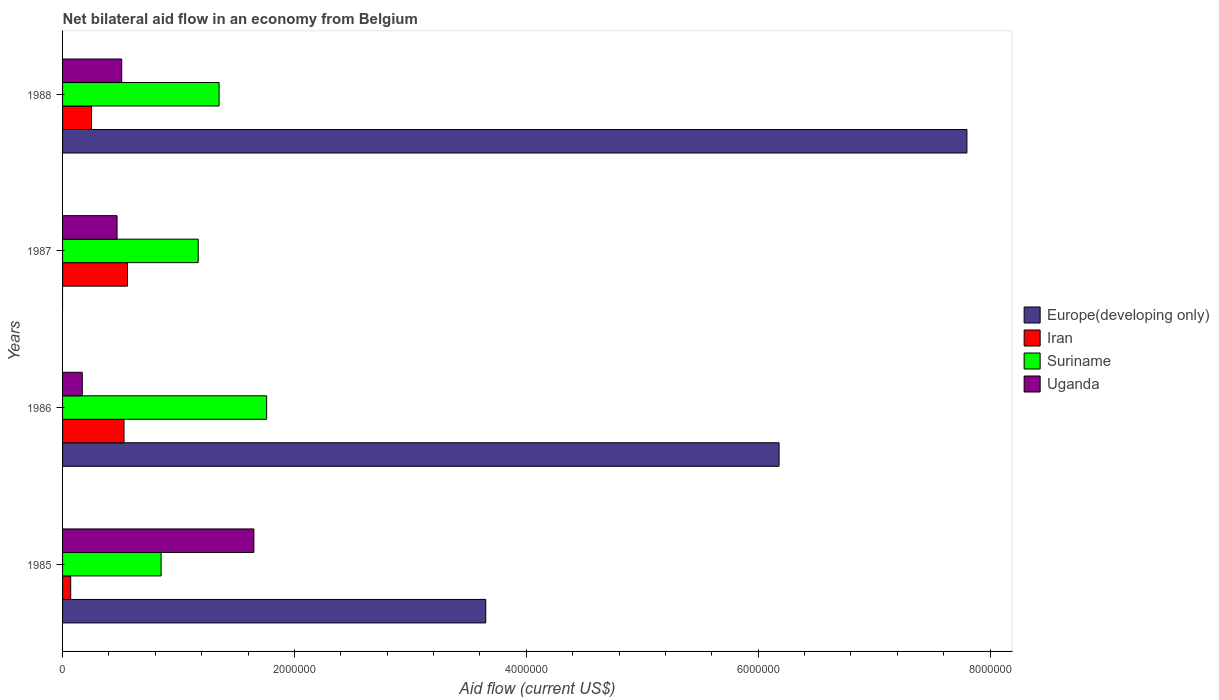How many different coloured bars are there?
Provide a succinct answer. 4. Are the number of bars per tick equal to the number of legend labels?
Your answer should be very brief. No. Are the number of bars on each tick of the Y-axis equal?
Give a very brief answer. No. How many bars are there on the 1st tick from the top?
Offer a terse response. 4. How many bars are there on the 3rd tick from the bottom?
Provide a short and direct response. 3. What is the label of the 1st group of bars from the top?
Offer a terse response. 1988. What is the net bilateral aid flow in Uganda in 1985?
Your answer should be very brief. 1.65e+06. Across all years, what is the maximum net bilateral aid flow in Europe(developing only)?
Provide a short and direct response. 7.80e+06. Across all years, what is the minimum net bilateral aid flow in Suriname?
Keep it short and to the point. 8.50e+05. What is the total net bilateral aid flow in Europe(developing only) in the graph?
Your answer should be compact. 1.76e+07. What is the difference between the net bilateral aid flow in Suriname in 1985 and that in 1987?
Give a very brief answer. -3.20e+05. What is the difference between the net bilateral aid flow in Europe(developing only) in 1985 and the net bilateral aid flow in Iran in 1986?
Ensure brevity in your answer.  3.12e+06. In the year 1986, what is the difference between the net bilateral aid flow in Iran and net bilateral aid flow in Suriname?
Your response must be concise. -1.23e+06. In how many years, is the net bilateral aid flow in Europe(developing only) greater than 5200000 US$?
Give a very brief answer. 2. What is the ratio of the net bilateral aid flow in Iran in 1986 to that in 1988?
Offer a terse response. 2.12. Is the net bilateral aid flow in Uganda in 1986 less than that in 1988?
Make the answer very short. Yes. Is the difference between the net bilateral aid flow in Iran in 1987 and 1988 greater than the difference between the net bilateral aid flow in Suriname in 1987 and 1988?
Provide a succinct answer. Yes. What is the difference between the highest and the second highest net bilateral aid flow in Suriname?
Ensure brevity in your answer.  4.10e+05. What is the difference between the highest and the lowest net bilateral aid flow in Europe(developing only)?
Your answer should be very brief. 7.80e+06. In how many years, is the net bilateral aid flow in Uganda greater than the average net bilateral aid flow in Uganda taken over all years?
Provide a succinct answer. 1. Is it the case that in every year, the sum of the net bilateral aid flow in Suriname and net bilateral aid flow in Iran is greater than the sum of net bilateral aid flow in Uganda and net bilateral aid flow in Europe(developing only)?
Offer a terse response. No. Is it the case that in every year, the sum of the net bilateral aid flow in Europe(developing only) and net bilateral aid flow in Suriname is greater than the net bilateral aid flow in Uganda?
Offer a terse response. Yes. Are all the bars in the graph horizontal?
Give a very brief answer. Yes. How many years are there in the graph?
Offer a terse response. 4. What is the difference between two consecutive major ticks on the X-axis?
Your answer should be very brief. 2.00e+06. Are the values on the major ticks of X-axis written in scientific E-notation?
Make the answer very short. No. Does the graph contain any zero values?
Provide a succinct answer. Yes. Does the graph contain grids?
Provide a short and direct response. No. What is the title of the graph?
Your answer should be compact. Net bilateral aid flow in an economy from Belgium. Does "Fragile and conflict affected situations" appear as one of the legend labels in the graph?
Your answer should be very brief. No. What is the label or title of the X-axis?
Give a very brief answer. Aid flow (current US$). What is the Aid flow (current US$) in Europe(developing only) in 1985?
Your response must be concise. 3.65e+06. What is the Aid flow (current US$) in Suriname in 1985?
Provide a succinct answer. 8.50e+05. What is the Aid flow (current US$) of Uganda in 1985?
Ensure brevity in your answer.  1.65e+06. What is the Aid flow (current US$) of Europe(developing only) in 1986?
Offer a terse response. 6.18e+06. What is the Aid flow (current US$) in Iran in 1986?
Provide a succinct answer. 5.30e+05. What is the Aid flow (current US$) in Suriname in 1986?
Your answer should be very brief. 1.76e+06. What is the Aid flow (current US$) in Uganda in 1986?
Provide a short and direct response. 1.70e+05. What is the Aid flow (current US$) of Europe(developing only) in 1987?
Offer a terse response. 0. What is the Aid flow (current US$) in Iran in 1987?
Make the answer very short. 5.60e+05. What is the Aid flow (current US$) of Suriname in 1987?
Offer a terse response. 1.17e+06. What is the Aid flow (current US$) in Europe(developing only) in 1988?
Ensure brevity in your answer.  7.80e+06. What is the Aid flow (current US$) of Iran in 1988?
Your response must be concise. 2.50e+05. What is the Aid flow (current US$) in Suriname in 1988?
Offer a terse response. 1.35e+06. What is the Aid flow (current US$) of Uganda in 1988?
Give a very brief answer. 5.10e+05. Across all years, what is the maximum Aid flow (current US$) in Europe(developing only)?
Make the answer very short. 7.80e+06. Across all years, what is the maximum Aid flow (current US$) in Iran?
Make the answer very short. 5.60e+05. Across all years, what is the maximum Aid flow (current US$) in Suriname?
Give a very brief answer. 1.76e+06. Across all years, what is the maximum Aid flow (current US$) in Uganda?
Offer a very short reply. 1.65e+06. Across all years, what is the minimum Aid flow (current US$) in Iran?
Make the answer very short. 7.00e+04. Across all years, what is the minimum Aid flow (current US$) in Suriname?
Your response must be concise. 8.50e+05. Across all years, what is the minimum Aid flow (current US$) of Uganda?
Provide a short and direct response. 1.70e+05. What is the total Aid flow (current US$) of Europe(developing only) in the graph?
Keep it short and to the point. 1.76e+07. What is the total Aid flow (current US$) in Iran in the graph?
Offer a very short reply. 1.41e+06. What is the total Aid flow (current US$) of Suriname in the graph?
Keep it short and to the point. 5.13e+06. What is the total Aid flow (current US$) of Uganda in the graph?
Your response must be concise. 2.80e+06. What is the difference between the Aid flow (current US$) of Europe(developing only) in 1985 and that in 1986?
Give a very brief answer. -2.53e+06. What is the difference between the Aid flow (current US$) in Iran in 1985 and that in 1986?
Keep it short and to the point. -4.60e+05. What is the difference between the Aid flow (current US$) in Suriname in 1985 and that in 1986?
Your response must be concise. -9.10e+05. What is the difference between the Aid flow (current US$) in Uganda in 1985 and that in 1986?
Provide a short and direct response. 1.48e+06. What is the difference between the Aid flow (current US$) in Iran in 1985 and that in 1987?
Give a very brief answer. -4.90e+05. What is the difference between the Aid flow (current US$) in Suriname in 1985 and that in 1987?
Keep it short and to the point. -3.20e+05. What is the difference between the Aid flow (current US$) of Uganda in 1985 and that in 1987?
Ensure brevity in your answer.  1.18e+06. What is the difference between the Aid flow (current US$) in Europe(developing only) in 1985 and that in 1988?
Your answer should be compact. -4.15e+06. What is the difference between the Aid flow (current US$) of Iran in 1985 and that in 1988?
Provide a short and direct response. -1.80e+05. What is the difference between the Aid flow (current US$) in Suriname in 1985 and that in 1988?
Ensure brevity in your answer.  -5.00e+05. What is the difference between the Aid flow (current US$) in Uganda in 1985 and that in 1988?
Your answer should be compact. 1.14e+06. What is the difference between the Aid flow (current US$) of Suriname in 1986 and that in 1987?
Your answer should be very brief. 5.90e+05. What is the difference between the Aid flow (current US$) of Europe(developing only) in 1986 and that in 1988?
Ensure brevity in your answer.  -1.62e+06. What is the difference between the Aid flow (current US$) of Uganda in 1987 and that in 1988?
Make the answer very short. -4.00e+04. What is the difference between the Aid flow (current US$) of Europe(developing only) in 1985 and the Aid flow (current US$) of Iran in 1986?
Make the answer very short. 3.12e+06. What is the difference between the Aid flow (current US$) of Europe(developing only) in 1985 and the Aid flow (current US$) of Suriname in 1986?
Keep it short and to the point. 1.89e+06. What is the difference between the Aid flow (current US$) of Europe(developing only) in 1985 and the Aid flow (current US$) of Uganda in 1986?
Your response must be concise. 3.48e+06. What is the difference between the Aid flow (current US$) in Iran in 1985 and the Aid flow (current US$) in Suriname in 1986?
Offer a terse response. -1.69e+06. What is the difference between the Aid flow (current US$) of Suriname in 1985 and the Aid flow (current US$) of Uganda in 1986?
Offer a terse response. 6.80e+05. What is the difference between the Aid flow (current US$) of Europe(developing only) in 1985 and the Aid flow (current US$) of Iran in 1987?
Offer a terse response. 3.09e+06. What is the difference between the Aid flow (current US$) of Europe(developing only) in 1985 and the Aid flow (current US$) of Suriname in 1987?
Provide a short and direct response. 2.48e+06. What is the difference between the Aid flow (current US$) of Europe(developing only) in 1985 and the Aid flow (current US$) of Uganda in 1987?
Provide a succinct answer. 3.18e+06. What is the difference between the Aid flow (current US$) of Iran in 1985 and the Aid flow (current US$) of Suriname in 1987?
Your response must be concise. -1.10e+06. What is the difference between the Aid flow (current US$) of Iran in 1985 and the Aid flow (current US$) of Uganda in 1987?
Ensure brevity in your answer.  -4.00e+05. What is the difference between the Aid flow (current US$) in Europe(developing only) in 1985 and the Aid flow (current US$) in Iran in 1988?
Your answer should be compact. 3.40e+06. What is the difference between the Aid flow (current US$) in Europe(developing only) in 1985 and the Aid flow (current US$) in Suriname in 1988?
Keep it short and to the point. 2.30e+06. What is the difference between the Aid flow (current US$) of Europe(developing only) in 1985 and the Aid flow (current US$) of Uganda in 1988?
Offer a terse response. 3.14e+06. What is the difference between the Aid flow (current US$) in Iran in 1985 and the Aid flow (current US$) in Suriname in 1988?
Ensure brevity in your answer.  -1.28e+06. What is the difference between the Aid flow (current US$) in Iran in 1985 and the Aid flow (current US$) in Uganda in 1988?
Provide a short and direct response. -4.40e+05. What is the difference between the Aid flow (current US$) of Europe(developing only) in 1986 and the Aid flow (current US$) of Iran in 1987?
Give a very brief answer. 5.62e+06. What is the difference between the Aid flow (current US$) in Europe(developing only) in 1986 and the Aid flow (current US$) in Suriname in 1987?
Keep it short and to the point. 5.01e+06. What is the difference between the Aid flow (current US$) of Europe(developing only) in 1986 and the Aid flow (current US$) of Uganda in 1987?
Ensure brevity in your answer.  5.71e+06. What is the difference between the Aid flow (current US$) of Iran in 1986 and the Aid flow (current US$) of Suriname in 1987?
Your response must be concise. -6.40e+05. What is the difference between the Aid flow (current US$) in Suriname in 1986 and the Aid flow (current US$) in Uganda in 1987?
Offer a very short reply. 1.29e+06. What is the difference between the Aid flow (current US$) of Europe(developing only) in 1986 and the Aid flow (current US$) of Iran in 1988?
Provide a short and direct response. 5.93e+06. What is the difference between the Aid flow (current US$) in Europe(developing only) in 1986 and the Aid flow (current US$) in Suriname in 1988?
Your response must be concise. 4.83e+06. What is the difference between the Aid flow (current US$) of Europe(developing only) in 1986 and the Aid flow (current US$) of Uganda in 1988?
Make the answer very short. 5.67e+06. What is the difference between the Aid flow (current US$) in Iran in 1986 and the Aid flow (current US$) in Suriname in 1988?
Provide a short and direct response. -8.20e+05. What is the difference between the Aid flow (current US$) in Suriname in 1986 and the Aid flow (current US$) in Uganda in 1988?
Offer a very short reply. 1.25e+06. What is the difference between the Aid flow (current US$) in Iran in 1987 and the Aid flow (current US$) in Suriname in 1988?
Provide a short and direct response. -7.90e+05. What is the difference between the Aid flow (current US$) of Iran in 1987 and the Aid flow (current US$) of Uganda in 1988?
Provide a short and direct response. 5.00e+04. What is the difference between the Aid flow (current US$) of Suriname in 1987 and the Aid flow (current US$) of Uganda in 1988?
Give a very brief answer. 6.60e+05. What is the average Aid flow (current US$) of Europe(developing only) per year?
Provide a succinct answer. 4.41e+06. What is the average Aid flow (current US$) in Iran per year?
Keep it short and to the point. 3.52e+05. What is the average Aid flow (current US$) of Suriname per year?
Offer a terse response. 1.28e+06. What is the average Aid flow (current US$) of Uganda per year?
Offer a very short reply. 7.00e+05. In the year 1985, what is the difference between the Aid flow (current US$) in Europe(developing only) and Aid flow (current US$) in Iran?
Offer a very short reply. 3.58e+06. In the year 1985, what is the difference between the Aid flow (current US$) of Europe(developing only) and Aid flow (current US$) of Suriname?
Ensure brevity in your answer.  2.80e+06. In the year 1985, what is the difference between the Aid flow (current US$) in Europe(developing only) and Aid flow (current US$) in Uganda?
Provide a succinct answer. 2.00e+06. In the year 1985, what is the difference between the Aid flow (current US$) of Iran and Aid flow (current US$) of Suriname?
Give a very brief answer. -7.80e+05. In the year 1985, what is the difference between the Aid flow (current US$) of Iran and Aid flow (current US$) of Uganda?
Give a very brief answer. -1.58e+06. In the year 1985, what is the difference between the Aid flow (current US$) in Suriname and Aid flow (current US$) in Uganda?
Keep it short and to the point. -8.00e+05. In the year 1986, what is the difference between the Aid flow (current US$) of Europe(developing only) and Aid flow (current US$) of Iran?
Keep it short and to the point. 5.65e+06. In the year 1986, what is the difference between the Aid flow (current US$) of Europe(developing only) and Aid flow (current US$) of Suriname?
Your answer should be very brief. 4.42e+06. In the year 1986, what is the difference between the Aid flow (current US$) of Europe(developing only) and Aid flow (current US$) of Uganda?
Provide a short and direct response. 6.01e+06. In the year 1986, what is the difference between the Aid flow (current US$) in Iran and Aid flow (current US$) in Suriname?
Your answer should be very brief. -1.23e+06. In the year 1986, what is the difference between the Aid flow (current US$) in Iran and Aid flow (current US$) in Uganda?
Ensure brevity in your answer.  3.60e+05. In the year 1986, what is the difference between the Aid flow (current US$) of Suriname and Aid flow (current US$) of Uganda?
Your answer should be compact. 1.59e+06. In the year 1987, what is the difference between the Aid flow (current US$) in Iran and Aid flow (current US$) in Suriname?
Your response must be concise. -6.10e+05. In the year 1987, what is the difference between the Aid flow (current US$) of Iran and Aid flow (current US$) of Uganda?
Offer a very short reply. 9.00e+04. In the year 1987, what is the difference between the Aid flow (current US$) in Suriname and Aid flow (current US$) in Uganda?
Offer a very short reply. 7.00e+05. In the year 1988, what is the difference between the Aid flow (current US$) of Europe(developing only) and Aid flow (current US$) of Iran?
Offer a terse response. 7.55e+06. In the year 1988, what is the difference between the Aid flow (current US$) of Europe(developing only) and Aid flow (current US$) of Suriname?
Provide a succinct answer. 6.45e+06. In the year 1988, what is the difference between the Aid flow (current US$) in Europe(developing only) and Aid flow (current US$) in Uganda?
Provide a succinct answer. 7.29e+06. In the year 1988, what is the difference between the Aid flow (current US$) of Iran and Aid flow (current US$) of Suriname?
Provide a short and direct response. -1.10e+06. In the year 1988, what is the difference between the Aid flow (current US$) in Iran and Aid flow (current US$) in Uganda?
Your answer should be compact. -2.60e+05. In the year 1988, what is the difference between the Aid flow (current US$) in Suriname and Aid flow (current US$) in Uganda?
Make the answer very short. 8.40e+05. What is the ratio of the Aid flow (current US$) in Europe(developing only) in 1985 to that in 1986?
Provide a short and direct response. 0.59. What is the ratio of the Aid flow (current US$) of Iran in 1985 to that in 1986?
Make the answer very short. 0.13. What is the ratio of the Aid flow (current US$) of Suriname in 1985 to that in 1986?
Keep it short and to the point. 0.48. What is the ratio of the Aid flow (current US$) in Uganda in 1985 to that in 1986?
Your answer should be compact. 9.71. What is the ratio of the Aid flow (current US$) of Iran in 1985 to that in 1987?
Provide a succinct answer. 0.12. What is the ratio of the Aid flow (current US$) of Suriname in 1985 to that in 1987?
Offer a very short reply. 0.73. What is the ratio of the Aid flow (current US$) in Uganda in 1985 to that in 1987?
Keep it short and to the point. 3.51. What is the ratio of the Aid flow (current US$) of Europe(developing only) in 1985 to that in 1988?
Your answer should be compact. 0.47. What is the ratio of the Aid flow (current US$) in Iran in 1985 to that in 1988?
Keep it short and to the point. 0.28. What is the ratio of the Aid flow (current US$) of Suriname in 1985 to that in 1988?
Your response must be concise. 0.63. What is the ratio of the Aid flow (current US$) of Uganda in 1985 to that in 1988?
Make the answer very short. 3.24. What is the ratio of the Aid flow (current US$) of Iran in 1986 to that in 1987?
Ensure brevity in your answer.  0.95. What is the ratio of the Aid flow (current US$) of Suriname in 1986 to that in 1987?
Provide a short and direct response. 1.5. What is the ratio of the Aid flow (current US$) in Uganda in 1986 to that in 1987?
Your response must be concise. 0.36. What is the ratio of the Aid flow (current US$) in Europe(developing only) in 1986 to that in 1988?
Ensure brevity in your answer.  0.79. What is the ratio of the Aid flow (current US$) of Iran in 1986 to that in 1988?
Your response must be concise. 2.12. What is the ratio of the Aid flow (current US$) in Suriname in 1986 to that in 1988?
Keep it short and to the point. 1.3. What is the ratio of the Aid flow (current US$) in Iran in 1987 to that in 1988?
Keep it short and to the point. 2.24. What is the ratio of the Aid flow (current US$) of Suriname in 1987 to that in 1988?
Provide a succinct answer. 0.87. What is the ratio of the Aid flow (current US$) of Uganda in 1987 to that in 1988?
Your answer should be compact. 0.92. What is the difference between the highest and the second highest Aid flow (current US$) in Europe(developing only)?
Your answer should be compact. 1.62e+06. What is the difference between the highest and the second highest Aid flow (current US$) of Suriname?
Give a very brief answer. 4.10e+05. What is the difference between the highest and the second highest Aid flow (current US$) in Uganda?
Your answer should be very brief. 1.14e+06. What is the difference between the highest and the lowest Aid flow (current US$) of Europe(developing only)?
Make the answer very short. 7.80e+06. What is the difference between the highest and the lowest Aid flow (current US$) in Suriname?
Your answer should be very brief. 9.10e+05. What is the difference between the highest and the lowest Aid flow (current US$) in Uganda?
Your answer should be compact. 1.48e+06. 